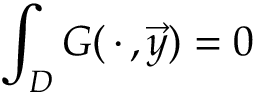<formula> <loc_0><loc_0><loc_500><loc_500>\int _ { D } G ( \, \cdot \, , \vec { y } ) = 0</formula> 